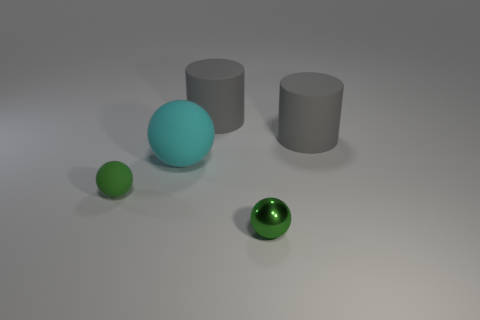Subtract all gray cylinders. How many were subtracted if there are1gray cylinders left? 1 Subtract all small spheres. How many spheres are left? 1 Subtract all brown cubes. How many green balls are left? 2 Add 1 big rubber cylinders. How many objects exist? 6 Subtract all cylinders. How many objects are left? 3 Add 2 small brown metallic cylinders. How many small brown metallic cylinders exist? 2 Subtract 0 red blocks. How many objects are left? 5 Subtract all small metal balls. Subtract all big matte balls. How many objects are left? 3 Add 1 cyan rubber objects. How many cyan rubber objects are left? 2 